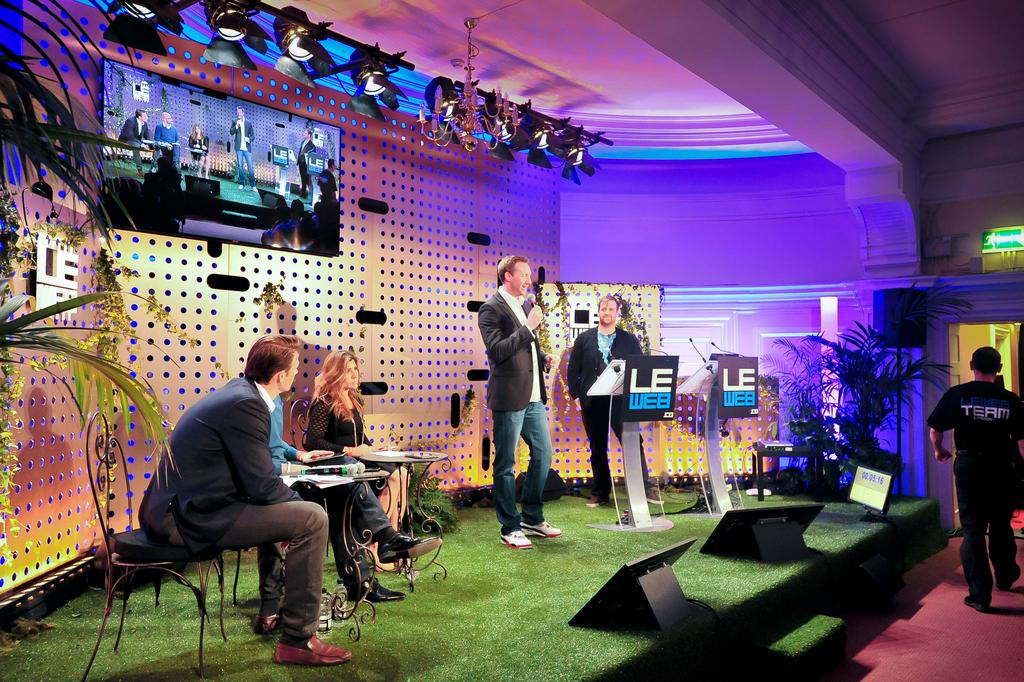What is the main subject of the image? The main subject of the image is a man standing in the middle of the image. What is the man holding in the image? The man is holding a microphone. What is the man wearing in the image? The man is wearing a coat. What can be seen on the left side of the image? There are people sitting on chairs on the left side of the image. What is present on the wall in the image? There is a television on the wall. What industry does the expert in the image specialize in? There is no expert present in the image, only a man holding a microphone. What is the relationship between the man and the people sitting on chairs in the image? The relationship between the man and the people sitting on chairs cannot be determined from the image alone. 